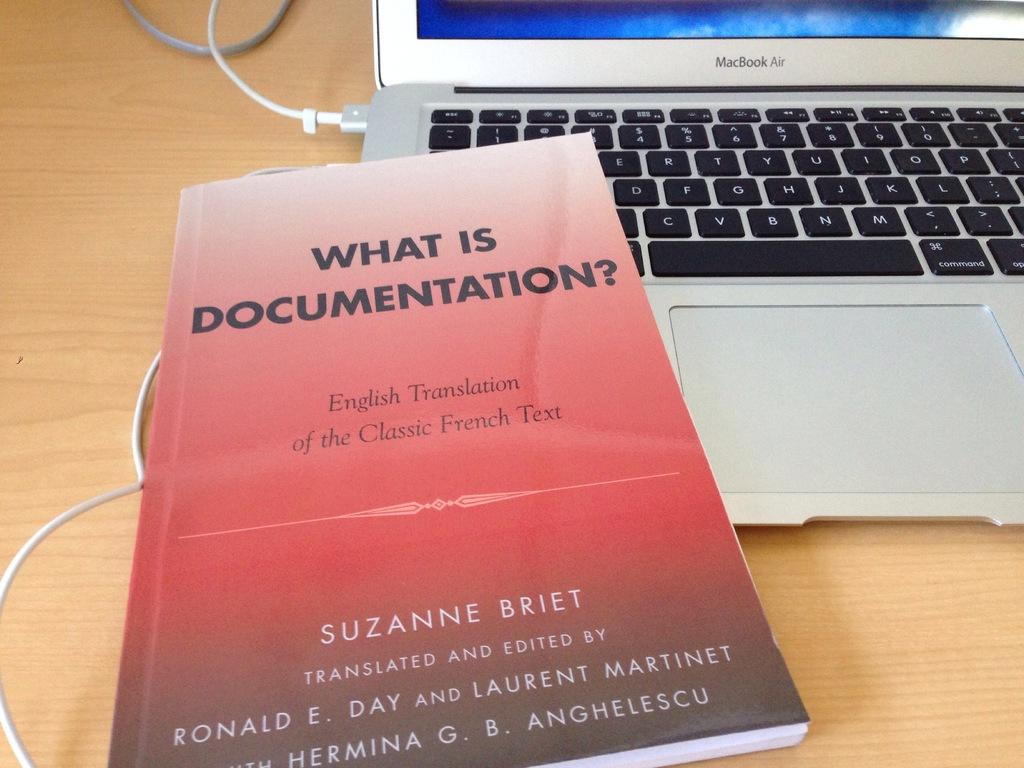<image>
Share a concise interpretation of the image provided. An English translation of a classic french text book is sitting on a MacBook Air. 